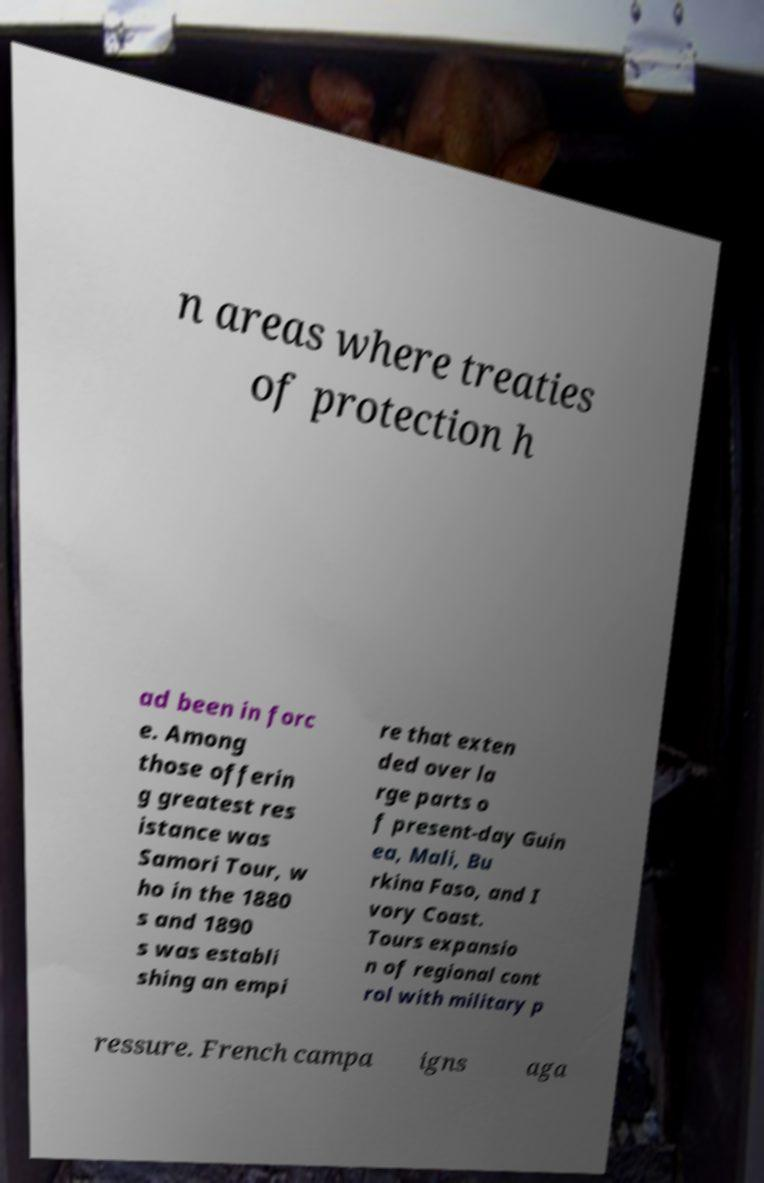Please identify and transcribe the text found in this image. n areas where treaties of protection h ad been in forc e. Among those offerin g greatest res istance was Samori Tour, w ho in the 1880 s and 1890 s was establi shing an empi re that exten ded over la rge parts o f present-day Guin ea, Mali, Bu rkina Faso, and I vory Coast. Tours expansio n of regional cont rol with military p ressure. French campa igns aga 